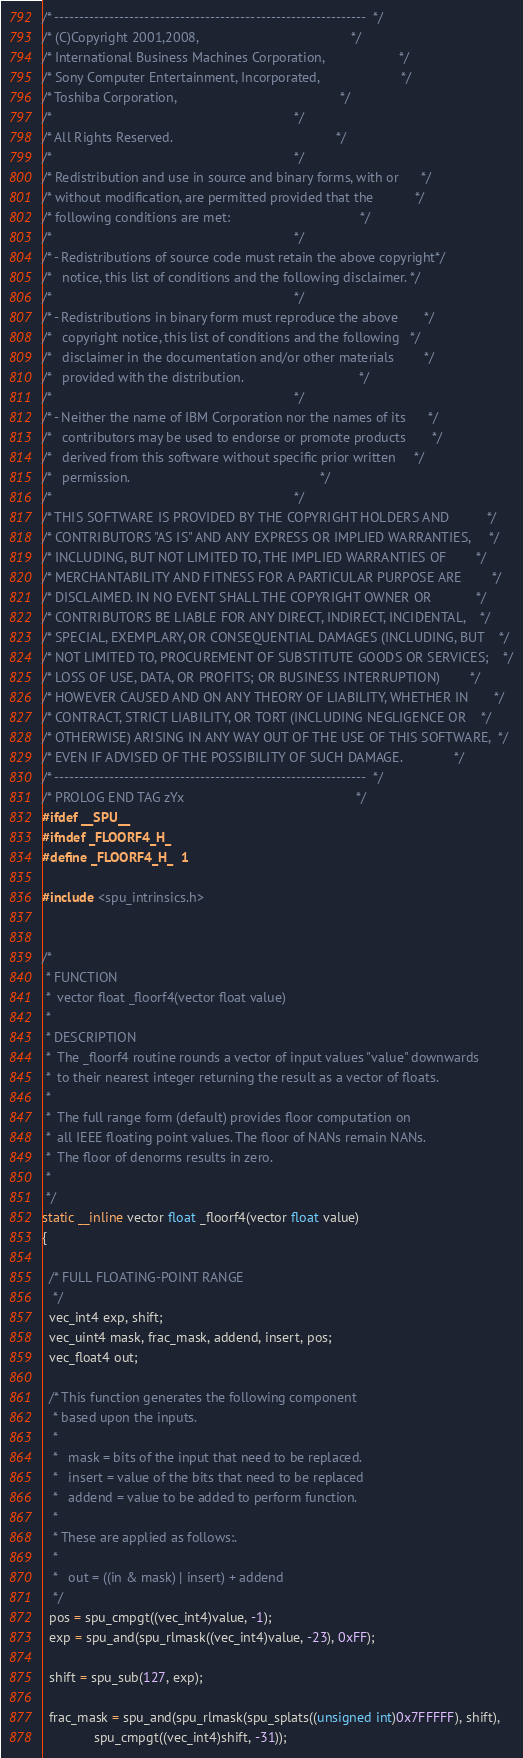<code> <loc_0><loc_0><loc_500><loc_500><_C_>/* --------------------------------------------------------------  */
/* (C)Copyright 2001,2008,                                         */
/* International Business Machines Corporation,                    */
/* Sony Computer Entertainment, Incorporated,                      */
/* Toshiba Corporation,                                            */
/*                                                                 */
/* All Rights Reserved.                                            */
/*                                                                 */
/* Redistribution and use in source and binary forms, with or      */
/* without modification, are permitted provided that the           */
/* following conditions are met:                                   */
/*                                                                 */
/* - Redistributions of source code must retain the above copyright*/
/*   notice, this list of conditions and the following disclaimer. */
/*                                                                 */
/* - Redistributions in binary form must reproduce the above       */
/*   copyright notice, this list of conditions and the following   */
/*   disclaimer in the documentation and/or other materials        */
/*   provided with the distribution.                               */
/*                                                                 */
/* - Neither the name of IBM Corporation nor the names of its      */
/*   contributors may be used to endorse or promote products       */
/*   derived from this software without specific prior written     */
/*   permission.                                                   */
/*                                                                 */
/* THIS SOFTWARE IS PROVIDED BY THE COPYRIGHT HOLDERS AND          */
/* CONTRIBUTORS "AS IS" AND ANY EXPRESS OR IMPLIED WARRANTIES,     */
/* INCLUDING, BUT NOT LIMITED TO, THE IMPLIED WARRANTIES OF        */
/* MERCHANTABILITY AND FITNESS FOR A PARTICULAR PURPOSE ARE        */
/* DISCLAIMED. IN NO EVENT SHALL THE COPYRIGHT OWNER OR            */
/* CONTRIBUTORS BE LIABLE FOR ANY DIRECT, INDIRECT, INCIDENTAL,    */
/* SPECIAL, EXEMPLARY, OR CONSEQUENTIAL DAMAGES (INCLUDING, BUT    */
/* NOT LIMITED TO, PROCUREMENT OF SUBSTITUTE GOODS OR SERVICES;    */
/* LOSS OF USE, DATA, OR PROFITS; OR BUSINESS INTERRUPTION)        */
/* HOWEVER CAUSED AND ON ANY THEORY OF LIABILITY, WHETHER IN       */
/* CONTRACT, STRICT LIABILITY, OR TORT (INCLUDING NEGLIGENCE OR    */
/* OTHERWISE) ARISING IN ANY WAY OUT OF THE USE OF THIS SOFTWARE,  */
/* EVEN IF ADVISED OF THE POSSIBILITY OF SUCH DAMAGE.              */
/* --------------------------------------------------------------  */
/* PROLOG END TAG zYx                                              */
#ifdef __SPU__
#ifndef _FLOORF4_H_
#define _FLOORF4_H_	1

#include <spu_intrinsics.h>


/*
 * FUNCTION
 *	vector float _floorf4(vector float value)
 *
 * DESCRIPTION
 *	The _floorf4 routine rounds a vector of input values "value" downwards
 *	to their nearest integer returning the result as a vector of floats. 
 *
 *	The full range form (default) provides floor computation on 
 *	all IEEE floating point values. The floor of NANs remain NANs.
 *	The floor of denorms results in zero.
 *
 */
static __inline vector float _floorf4(vector float value)
{

  /* FULL FLOATING-POINT RANGE 
   */
  vec_int4 exp, shift;
  vec_uint4 mask, frac_mask, addend, insert, pos;
  vec_float4 out;

  /* This function generates the following component
   * based upon the inputs.
   *
   *   mask = bits of the input that need to be replaced.
   *   insert = value of the bits that need to be replaced
   *   addend = value to be added to perform function.
   *
   * These are applied as follows:.
   *
   *   out = ((in & mask) | insert) + addend
   */
  pos = spu_cmpgt((vec_int4)value, -1);
  exp = spu_and(spu_rlmask((vec_int4)value, -23), 0xFF);

  shift = spu_sub(127, exp);

  frac_mask = spu_and(spu_rlmask(spu_splats((unsigned int)0x7FFFFF), shift),
		      spu_cmpgt((vec_int4)shift, -31));
</code> 